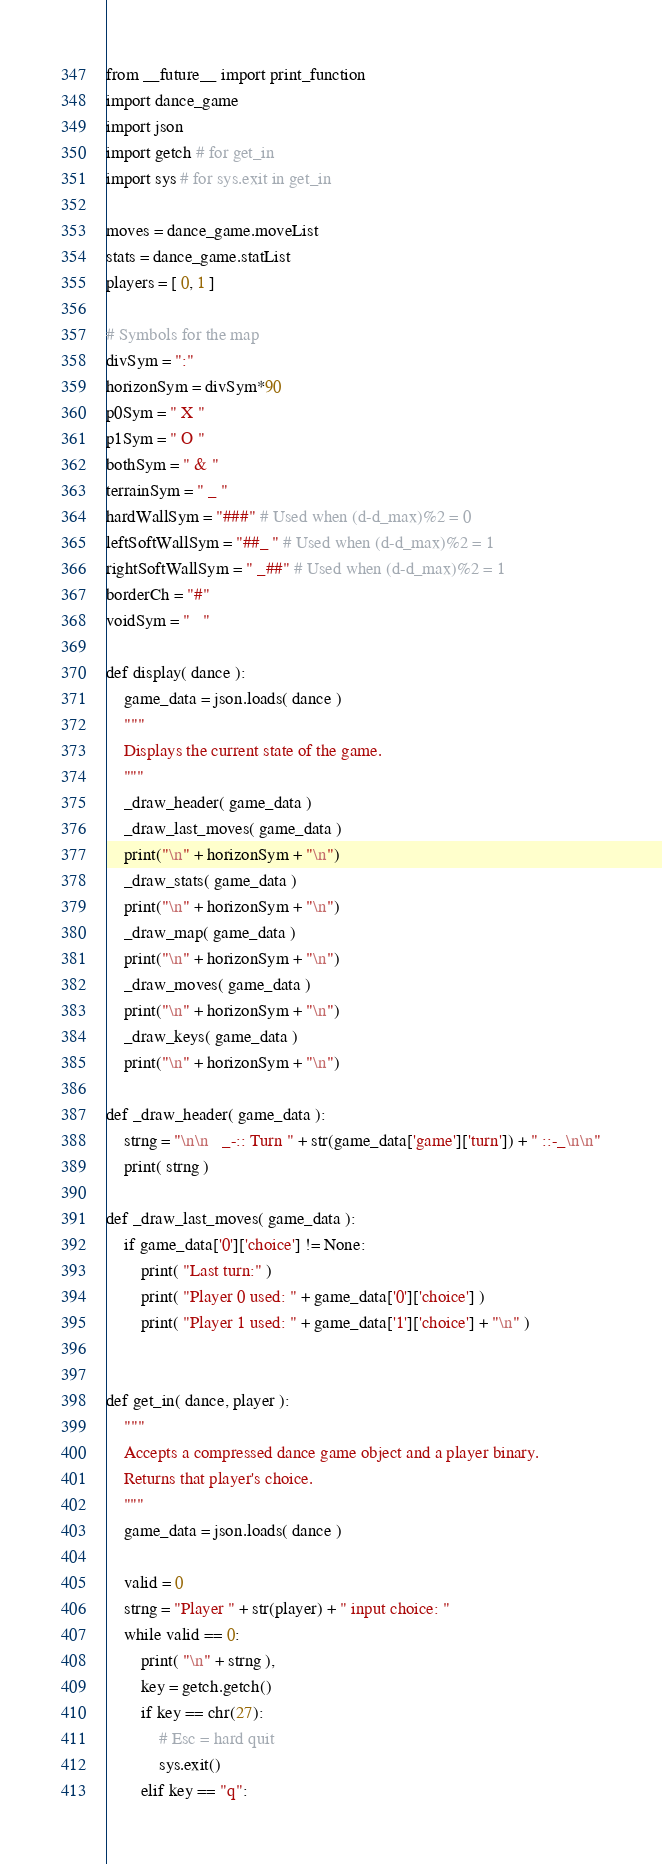<code> <loc_0><loc_0><loc_500><loc_500><_Python_>from __future__ import print_function
import dance_game
import json
import getch # for get_in
import sys # for sys.exit in get_in

moves = dance_game.moveList
stats = dance_game.statList
players = [ 0, 1 ]

# Symbols for the map
divSym = ":"
horizonSym = divSym*90
p0Sym = " X "
p1Sym = " O "
bothSym = " & "
terrainSym = " _ "
hardWallSym = "###" # Used when (d-d_max)%2 = 0
leftSoftWallSym = "##_ " # Used when (d-d_max)%2 = 1
rightSoftWallSym = " _##" # Used when (d-d_max)%2 = 1
borderCh = "#"
voidSym = "   "

def display( dance ):
	game_data = json.loads( dance )
	"""
	Displays the current state of the game.
	"""
	_draw_header( game_data )
	_draw_last_moves( game_data )
	print("\n" + horizonSym + "\n")
	_draw_stats( game_data )
	print("\n" + horizonSym + "\n")
	_draw_map( game_data )
	print("\n" + horizonSym + "\n")
	_draw_moves( game_data )
	print("\n" + horizonSym + "\n")
	_draw_keys( game_data )
	print("\n" + horizonSym + "\n")

def _draw_header( game_data ):
	strng = "\n\n   _-:: Turn " + str(game_data['game']['turn']) + " ::-_\n\n"
	print( strng )

def _draw_last_moves( game_data ):
	if game_data['0']['choice'] != None:
		print( "Last turn:" )
		print( "Player 0 used: " + game_data['0']['choice'] )
		print( "Player 1 used: " + game_data['1']['choice'] + "\n" )


def get_in( dance, player ):
	"""
	Accepts a compressed dance game object and a player binary.
	Returns that player's choice.
	"""
	game_data = json.loads( dance )

	valid = 0
	strng = "Player " + str(player) + " input choice: "
	while valid == 0:
		print( "\n" + strng ),
		key = getch.getch()
		if key == chr(27):
			# Esc = hard quit
			sys.exit()
		elif key == "q":</code> 